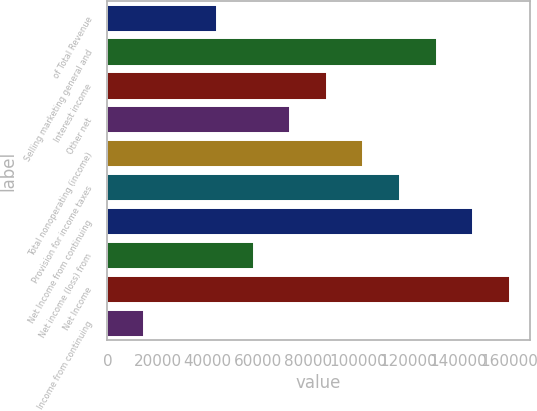<chart> <loc_0><loc_0><loc_500><loc_500><bar_chart><fcel>of Total Revenue<fcel>Selling marketing general and<fcel>Interest income<fcel>Other net<fcel>Total nonoperating (income)<fcel>Provision for income taxes<fcel>Net Income from continuing<fcel>Net income (loss) from<fcel>Net Income<fcel>Income from continuing<nl><fcel>43746.4<fcel>131239<fcel>87492.7<fcel>72910.6<fcel>102075<fcel>116657<fcel>145821<fcel>58328.5<fcel>160403<fcel>14582.2<nl></chart> 